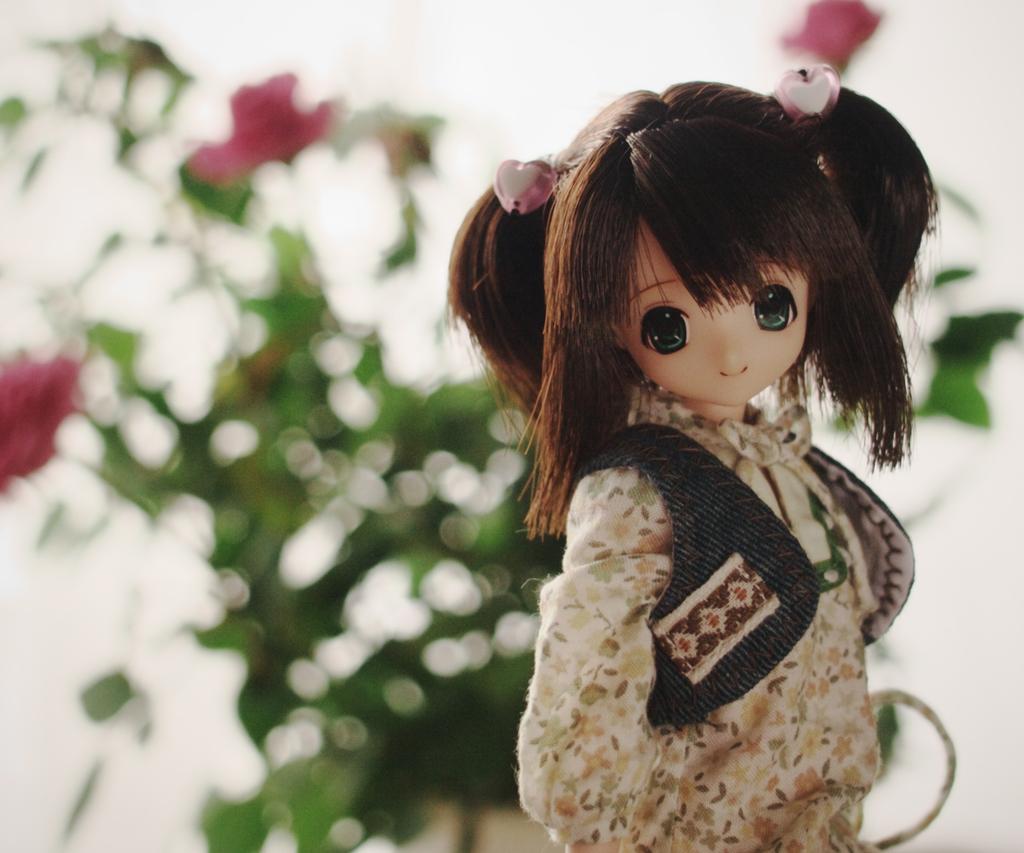Could you give a brief overview of what you see in this image? In this image there is a small girl toy in the middle. In the background there is a plant to which there are pink color flowers. 